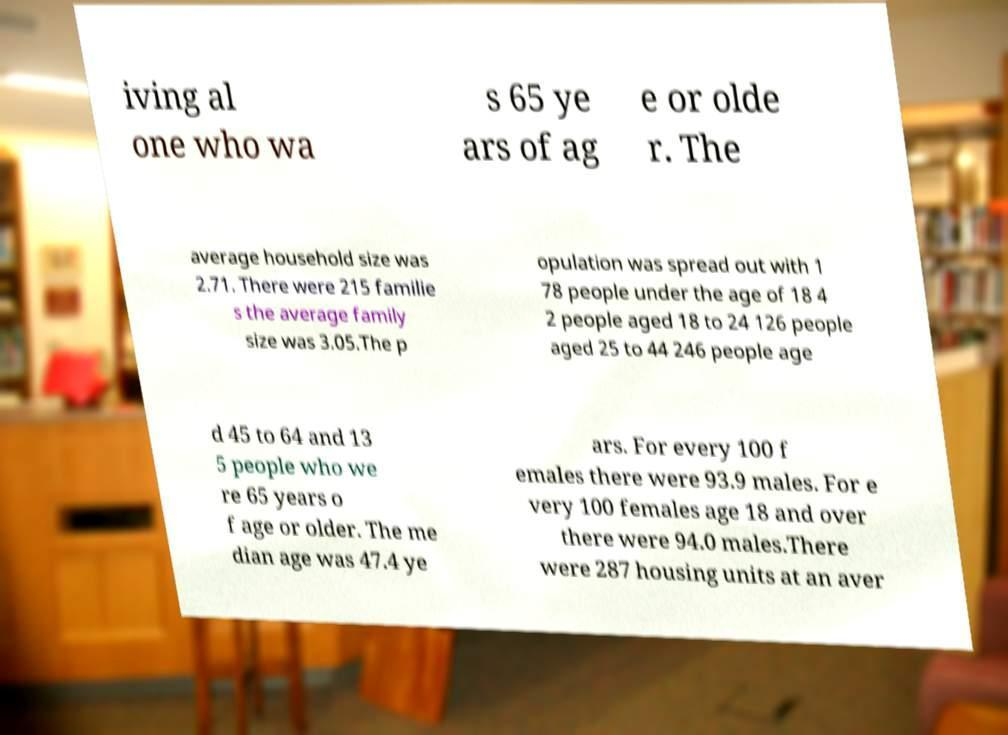Please identify and transcribe the text found in this image. iving al one who wa s 65 ye ars of ag e or olde r. The average household size was 2.71. There were 215 familie s the average family size was 3.05.The p opulation was spread out with 1 78 people under the age of 18 4 2 people aged 18 to 24 126 people aged 25 to 44 246 people age d 45 to 64 and 13 5 people who we re 65 years o f age or older. The me dian age was 47.4 ye ars. For every 100 f emales there were 93.9 males. For e very 100 females age 18 and over there were 94.0 males.There were 287 housing units at an aver 